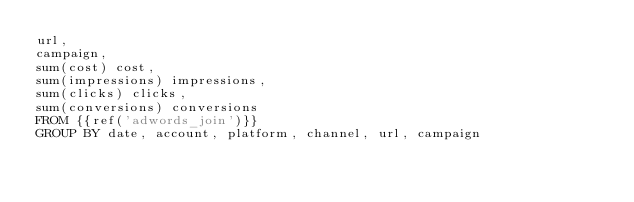Convert code to text. <code><loc_0><loc_0><loc_500><loc_500><_SQL_>url,
campaign,
sum(cost) cost,
sum(impressions) impressions,
sum(clicks) clicks,
sum(conversions) conversions
FROM {{ref('adwords_join')}}
GROUP BY date, account, platform, channel, url, campaign</code> 